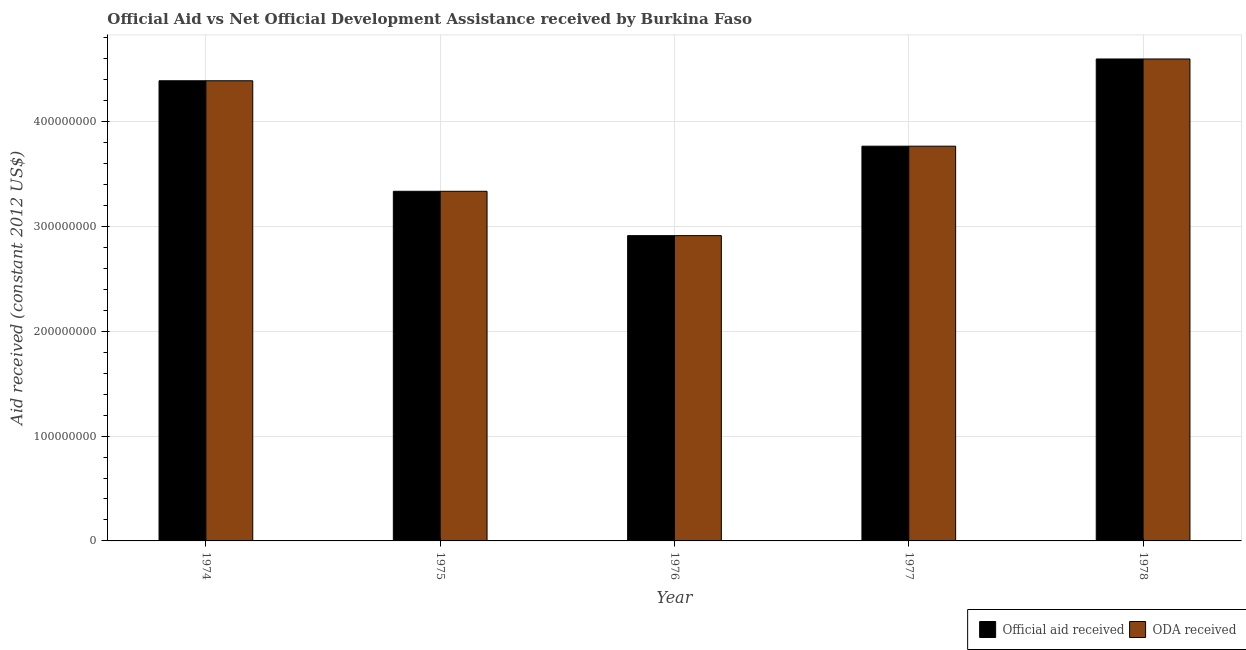Are the number of bars per tick equal to the number of legend labels?
Your answer should be compact. Yes. How many bars are there on the 2nd tick from the right?
Your answer should be compact. 2. What is the label of the 3rd group of bars from the left?
Your answer should be very brief. 1976. What is the official aid received in 1977?
Offer a very short reply. 3.77e+08. Across all years, what is the maximum oda received?
Offer a terse response. 4.60e+08. Across all years, what is the minimum official aid received?
Make the answer very short. 2.91e+08. In which year was the official aid received maximum?
Offer a terse response. 1978. In which year was the oda received minimum?
Provide a succinct answer. 1976. What is the total official aid received in the graph?
Keep it short and to the point. 1.90e+09. What is the difference between the oda received in 1976 and that in 1977?
Make the answer very short. -8.53e+07. What is the difference between the official aid received in 1974 and the oda received in 1978?
Ensure brevity in your answer.  -2.08e+07. What is the average oda received per year?
Your answer should be very brief. 3.80e+08. In the year 1977, what is the difference between the official aid received and oda received?
Provide a succinct answer. 0. In how many years, is the official aid received greater than 180000000 US$?
Offer a terse response. 5. What is the ratio of the oda received in 1975 to that in 1976?
Give a very brief answer. 1.15. What is the difference between the highest and the second highest official aid received?
Your response must be concise. 2.08e+07. What is the difference between the highest and the lowest oda received?
Give a very brief answer. 1.69e+08. What does the 1st bar from the left in 1976 represents?
Provide a succinct answer. Official aid received. What does the 2nd bar from the right in 1975 represents?
Provide a short and direct response. Official aid received. Are all the bars in the graph horizontal?
Your answer should be compact. No. What is the difference between two consecutive major ticks on the Y-axis?
Keep it short and to the point. 1.00e+08. Does the graph contain any zero values?
Offer a terse response. No. Does the graph contain grids?
Provide a short and direct response. Yes. How many legend labels are there?
Provide a succinct answer. 2. What is the title of the graph?
Ensure brevity in your answer.  Official Aid vs Net Official Development Assistance received by Burkina Faso . Does "Male labor force" appear as one of the legend labels in the graph?
Offer a very short reply. No. What is the label or title of the X-axis?
Keep it short and to the point. Year. What is the label or title of the Y-axis?
Your answer should be very brief. Aid received (constant 2012 US$). What is the Aid received (constant 2012 US$) in Official aid received in 1974?
Provide a succinct answer. 4.39e+08. What is the Aid received (constant 2012 US$) in ODA received in 1974?
Offer a very short reply. 4.39e+08. What is the Aid received (constant 2012 US$) of Official aid received in 1975?
Provide a succinct answer. 3.34e+08. What is the Aid received (constant 2012 US$) of ODA received in 1975?
Make the answer very short. 3.34e+08. What is the Aid received (constant 2012 US$) of Official aid received in 1976?
Your answer should be compact. 2.91e+08. What is the Aid received (constant 2012 US$) of ODA received in 1976?
Provide a succinct answer. 2.91e+08. What is the Aid received (constant 2012 US$) of Official aid received in 1977?
Make the answer very short. 3.77e+08. What is the Aid received (constant 2012 US$) of ODA received in 1977?
Keep it short and to the point. 3.77e+08. What is the Aid received (constant 2012 US$) of Official aid received in 1978?
Ensure brevity in your answer.  4.60e+08. What is the Aid received (constant 2012 US$) of ODA received in 1978?
Provide a succinct answer. 4.60e+08. Across all years, what is the maximum Aid received (constant 2012 US$) in Official aid received?
Your response must be concise. 4.60e+08. Across all years, what is the maximum Aid received (constant 2012 US$) in ODA received?
Ensure brevity in your answer.  4.60e+08. Across all years, what is the minimum Aid received (constant 2012 US$) of Official aid received?
Offer a terse response. 2.91e+08. Across all years, what is the minimum Aid received (constant 2012 US$) of ODA received?
Your answer should be compact. 2.91e+08. What is the total Aid received (constant 2012 US$) in Official aid received in the graph?
Your answer should be compact. 1.90e+09. What is the total Aid received (constant 2012 US$) in ODA received in the graph?
Keep it short and to the point. 1.90e+09. What is the difference between the Aid received (constant 2012 US$) of Official aid received in 1974 and that in 1975?
Provide a succinct answer. 1.05e+08. What is the difference between the Aid received (constant 2012 US$) in ODA received in 1974 and that in 1975?
Your answer should be compact. 1.05e+08. What is the difference between the Aid received (constant 2012 US$) in Official aid received in 1974 and that in 1976?
Ensure brevity in your answer.  1.48e+08. What is the difference between the Aid received (constant 2012 US$) of ODA received in 1974 and that in 1976?
Make the answer very short. 1.48e+08. What is the difference between the Aid received (constant 2012 US$) of Official aid received in 1974 and that in 1977?
Make the answer very short. 6.24e+07. What is the difference between the Aid received (constant 2012 US$) of ODA received in 1974 and that in 1977?
Offer a terse response. 6.24e+07. What is the difference between the Aid received (constant 2012 US$) of Official aid received in 1974 and that in 1978?
Provide a short and direct response. -2.08e+07. What is the difference between the Aid received (constant 2012 US$) in ODA received in 1974 and that in 1978?
Your answer should be very brief. -2.08e+07. What is the difference between the Aid received (constant 2012 US$) in Official aid received in 1975 and that in 1976?
Give a very brief answer. 4.23e+07. What is the difference between the Aid received (constant 2012 US$) of ODA received in 1975 and that in 1976?
Keep it short and to the point. 4.23e+07. What is the difference between the Aid received (constant 2012 US$) of Official aid received in 1975 and that in 1977?
Provide a short and direct response. -4.30e+07. What is the difference between the Aid received (constant 2012 US$) in ODA received in 1975 and that in 1977?
Offer a terse response. -4.30e+07. What is the difference between the Aid received (constant 2012 US$) in Official aid received in 1975 and that in 1978?
Your answer should be compact. -1.26e+08. What is the difference between the Aid received (constant 2012 US$) in ODA received in 1975 and that in 1978?
Keep it short and to the point. -1.26e+08. What is the difference between the Aid received (constant 2012 US$) of Official aid received in 1976 and that in 1977?
Your response must be concise. -8.53e+07. What is the difference between the Aid received (constant 2012 US$) in ODA received in 1976 and that in 1977?
Provide a succinct answer. -8.53e+07. What is the difference between the Aid received (constant 2012 US$) of Official aid received in 1976 and that in 1978?
Provide a short and direct response. -1.69e+08. What is the difference between the Aid received (constant 2012 US$) in ODA received in 1976 and that in 1978?
Your answer should be very brief. -1.69e+08. What is the difference between the Aid received (constant 2012 US$) of Official aid received in 1977 and that in 1978?
Give a very brief answer. -8.32e+07. What is the difference between the Aid received (constant 2012 US$) of ODA received in 1977 and that in 1978?
Keep it short and to the point. -8.32e+07. What is the difference between the Aid received (constant 2012 US$) of Official aid received in 1974 and the Aid received (constant 2012 US$) of ODA received in 1975?
Offer a very short reply. 1.05e+08. What is the difference between the Aid received (constant 2012 US$) of Official aid received in 1974 and the Aid received (constant 2012 US$) of ODA received in 1976?
Make the answer very short. 1.48e+08. What is the difference between the Aid received (constant 2012 US$) in Official aid received in 1974 and the Aid received (constant 2012 US$) in ODA received in 1977?
Your response must be concise. 6.24e+07. What is the difference between the Aid received (constant 2012 US$) in Official aid received in 1974 and the Aid received (constant 2012 US$) in ODA received in 1978?
Your answer should be very brief. -2.08e+07. What is the difference between the Aid received (constant 2012 US$) in Official aid received in 1975 and the Aid received (constant 2012 US$) in ODA received in 1976?
Give a very brief answer. 4.23e+07. What is the difference between the Aid received (constant 2012 US$) of Official aid received in 1975 and the Aid received (constant 2012 US$) of ODA received in 1977?
Offer a terse response. -4.30e+07. What is the difference between the Aid received (constant 2012 US$) in Official aid received in 1975 and the Aid received (constant 2012 US$) in ODA received in 1978?
Keep it short and to the point. -1.26e+08. What is the difference between the Aid received (constant 2012 US$) in Official aid received in 1976 and the Aid received (constant 2012 US$) in ODA received in 1977?
Your answer should be very brief. -8.53e+07. What is the difference between the Aid received (constant 2012 US$) in Official aid received in 1976 and the Aid received (constant 2012 US$) in ODA received in 1978?
Give a very brief answer. -1.69e+08. What is the difference between the Aid received (constant 2012 US$) of Official aid received in 1977 and the Aid received (constant 2012 US$) of ODA received in 1978?
Keep it short and to the point. -8.32e+07. What is the average Aid received (constant 2012 US$) of Official aid received per year?
Keep it short and to the point. 3.80e+08. What is the average Aid received (constant 2012 US$) in ODA received per year?
Provide a short and direct response. 3.80e+08. In the year 1974, what is the difference between the Aid received (constant 2012 US$) in Official aid received and Aid received (constant 2012 US$) in ODA received?
Your answer should be compact. 0. In the year 1976, what is the difference between the Aid received (constant 2012 US$) of Official aid received and Aid received (constant 2012 US$) of ODA received?
Offer a very short reply. 0. In the year 1978, what is the difference between the Aid received (constant 2012 US$) of Official aid received and Aid received (constant 2012 US$) of ODA received?
Your answer should be compact. 0. What is the ratio of the Aid received (constant 2012 US$) of Official aid received in 1974 to that in 1975?
Give a very brief answer. 1.32. What is the ratio of the Aid received (constant 2012 US$) in ODA received in 1974 to that in 1975?
Keep it short and to the point. 1.32. What is the ratio of the Aid received (constant 2012 US$) of Official aid received in 1974 to that in 1976?
Your answer should be compact. 1.51. What is the ratio of the Aid received (constant 2012 US$) of ODA received in 1974 to that in 1976?
Make the answer very short. 1.51. What is the ratio of the Aid received (constant 2012 US$) of Official aid received in 1974 to that in 1977?
Your response must be concise. 1.17. What is the ratio of the Aid received (constant 2012 US$) in ODA received in 1974 to that in 1977?
Ensure brevity in your answer.  1.17. What is the ratio of the Aid received (constant 2012 US$) of Official aid received in 1974 to that in 1978?
Offer a terse response. 0.95. What is the ratio of the Aid received (constant 2012 US$) of ODA received in 1974 to that in 1978?
Your answer should be very brief. 0.95. What is the ratio of the Aid received (constant 2012 US$) of Official aid received in 1975 to that in 1976?
Your response must be concise. 1.15. What is the ratio of the Aid received (constant 2012 US$) in ODA received in 1975 to that in 1976?
Your answer should be compact. 1.15. What is the ratio of the Aid received (constant 2012 US$) in Official aid received in 1975 to that in 1977?
Your response must be concise. 0.89. What is the ratio of the Aid received (constant 2012 US$) in ODA received in 1975 to that in 1977?
Your answer should be compact. 0.89. What is the ratio of the Aid received (constant 2012 US$) of Official aid received in 1975 to that in 1978?
Ensure brevity in your answer.  0.73. What is the ratio of the Aid received (constant 2012 US$) of ODA received in 1975 to that in 1978?
Offer a very short reply. 0.73. What is the ratio of the Aid received (constant 2012 US$) in Official aid received in 1976 to that in 1977?
Your response must be concise. 0.77. What is the ratio of the Aid received (constant 2012 US$) of ODA received in 1976 to that in 1977?
Give a very brief answer. 0.77. What is the ratio of the Aid received (constant 2012 US$) in Official aid received in 1976 to that in 1978?
Provide a succinct answer. 0.63. What is the ratio of the Aid received (constant 2012 US$) of ODA received in 1976 to that in 1978?
Provide a short and direct response. 0.63. What is the ratio of the Aid received (constant 2012 US$) in Official aid received in 1977 to that in 1978?
Provide a short and direct response. 0.82. What is the ratio of the Aid received (constant 2012 US$) in ODA received in 1977 to that in 1978?
Ensure brevity in your answer.  0.82. What is the difference between the highest and the second highest Aid received (constant 2012 US$) of Official aid received?
Keep it short and to the point. 2.08e+07. What is the difference between the highest and the second highest Aid received (constant 2012 US$) in ODA received?
Your response must be concise. 2.08e+07. What is the difference between the highest and the lowest Aid received (constant 2012 US$) of Official aid received?
Your response must be concise. 1.69e+08. What is the difference between the highest and the lowest Aid received (constant 2012 US$) in ODA received?
Your response must be concise. 1.69e+08. 